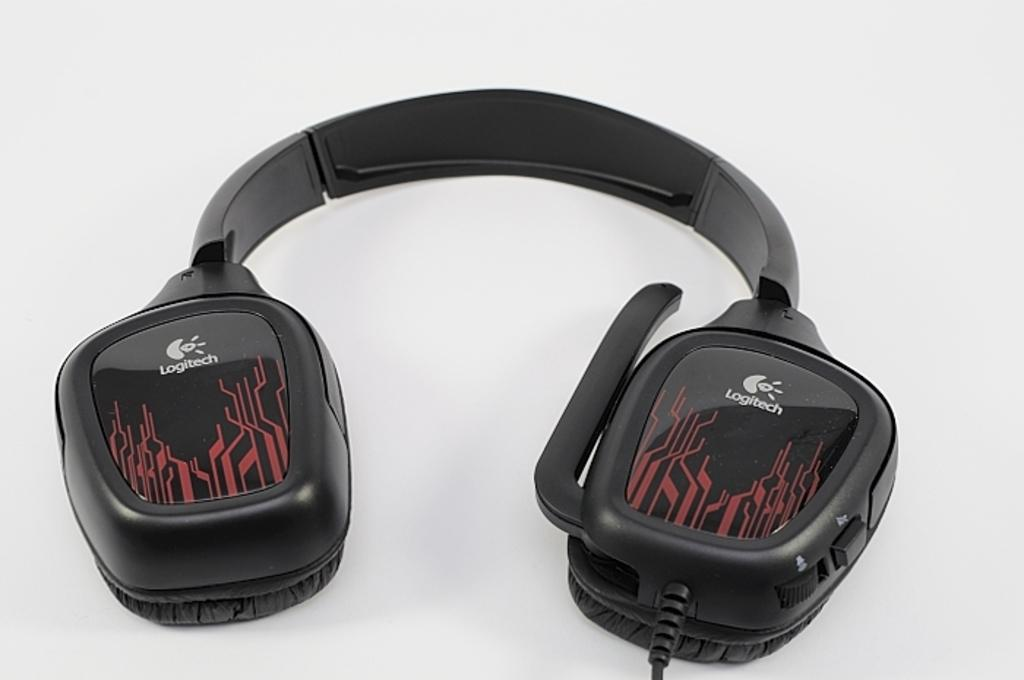<image>
Summarize the visual content of the image. A pair of headphones with a graphic picture and the labeling LOGITECH on them. 